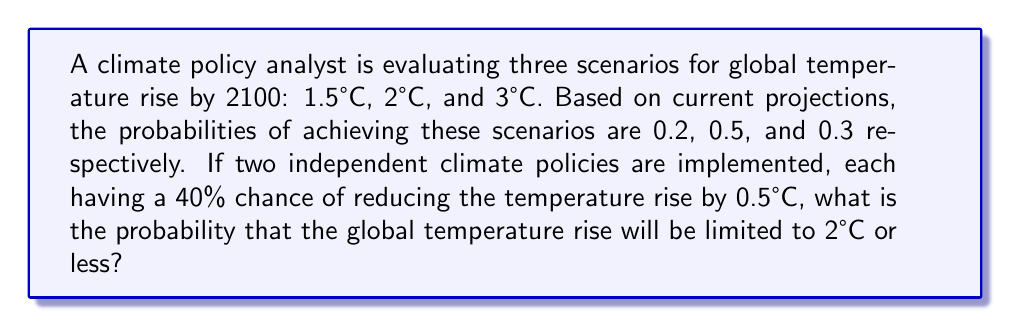Could you help me with this problem? Let's approach this step-by-step:

1) First, we need to calculate the probability of at least one policy succeeding:
   P(at least one policy succeeds) = 1 - P(both policies fail)
   = 1 - (0.6 * 0.6) = 1 - 0.36 = 0.64

2) Now, let's consider the effect of successful policies:
   - If no policy succeeds (probability 0.36), the original probabilities remain.
   - If at least one policy succeeds (probability 0.64), we shift the probabilities:
     The 3°C scenario becomes 2.5°C, the 2°C becomes 1.5°C, and the 1.5°C remains.

3) Let's calculate the probability of 2°C or less for each case:
   a) No policy succeeds (0.36 probability):
      P(2°C or less | no success) = 0.2 + 0.5 = 0.7

   b) At least one policy succeeds (0.64 probability):
      P(2°C or less | success) = 0.2 + 0.5 + 0.3 = 1

4) Now we can use the law of total probability:

   $$P(2°C or less) = P(no success) * P(2°C or less | no success) + P(success) * P(2°C or less | success)$$
   $$= 0.36 * 0.7 + 0.64 * 1$$
   $$= 0.252 + 0.64$$
   $$= 0.892$$

Therefore, the probability of limiting the global temperature rise to 2°C or less is 0.892 or 89.2%.
Answer: 0.892 